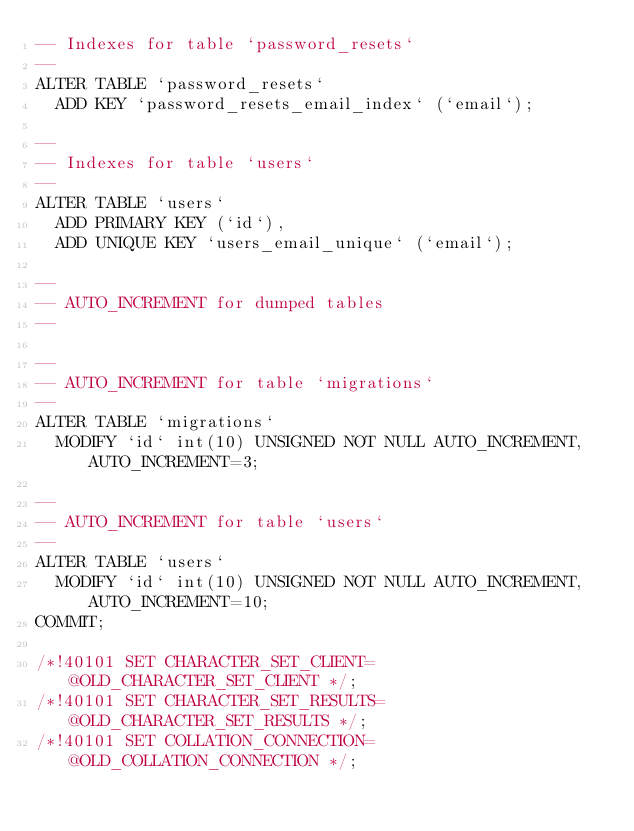<code> <loc_0><loc_0><loc_500><loc_500><_SQL_>-- Indexes for table `password_resets`
--
ALTER TABLE `password_resets`
  ADD KEY `password_resets_email_index` (`email`);

--
-- Indexes for table `users`
--
ALTER TABLE `users`
  ADD PRIMARY KEY (`id`),
  ADD UNIQUE KEY `users_email_unique` (`email`);

--
-- AUTO_INCREMENT for dumped tables
--

--
-- AUTO_INCREMENT for table `migrations`
--
ALTER TABLE `migrations`
  MODIFY `id` int(10) UNSIGNED NOT NULL AUTO_INCREMENT, AUTO_INCREMENT=3;

--
-- AUTO_INCREMENT for table `users`
--
ALTER TABLE `users`
  MODIFY `id` int(10) UNSIGNED NOT NULL AUTO_INCREMENT, AUTO_INCREMENT=10;
COMMIT;

/*!40101 SET CHARACTER_SET_CLIENT=@OLD_CHARACTER_SET_CLIENT */;
/*!40101 SET CHARACTER_SET_RESULTS=@OLD_CHARACTER_SET_RESULTS */;
/*!40101 SET COLLATION_CONNECTION=@OLD_COLLATION_CONNECTION */;
</code> 